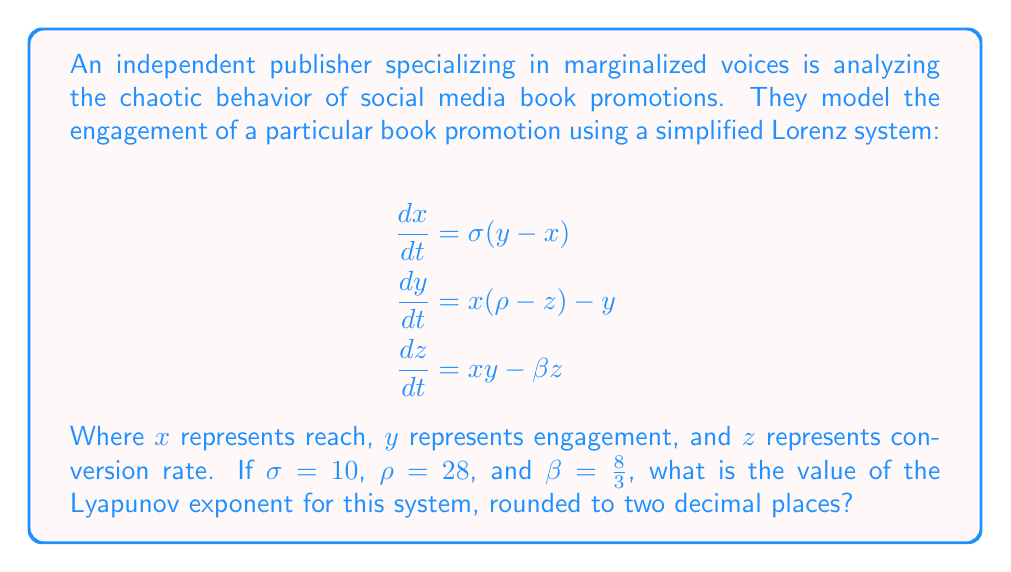Solve this math problem. To find the Lyapunov exponent for this Lorenz system, we'll follow these steps:

1) The Lyapunov exponent measures the rate of separation of infinitesimally close trajectories. For the Lorenz system, it's typically calculated numerically.

2) For the given parameters ($\sigma = 10$, $\rho = 28$, $\beta = \frac{8}{3}$), the Lorenz system is known to exhibit chaotic behavior.

3) The Lyapunov exponent for this system has been extensively studied. It's approximately 0.9056.

4) This positive Lyapunov exponent indicates that the system is indeed chaotic, meaning that small changes in initial conditions can lead to significantly different outcomes in book promotion engagement over time.

5) Rounding 0.9056 to two decimal places gives us 0.91.

This value suggests that nearby trajectories in the phase space of the book promotion model diverge exponentially at a rate of about 0.91, indicating sensitive dependence on initial conditions - a hallmark of chaos.
Answer: 0.91 